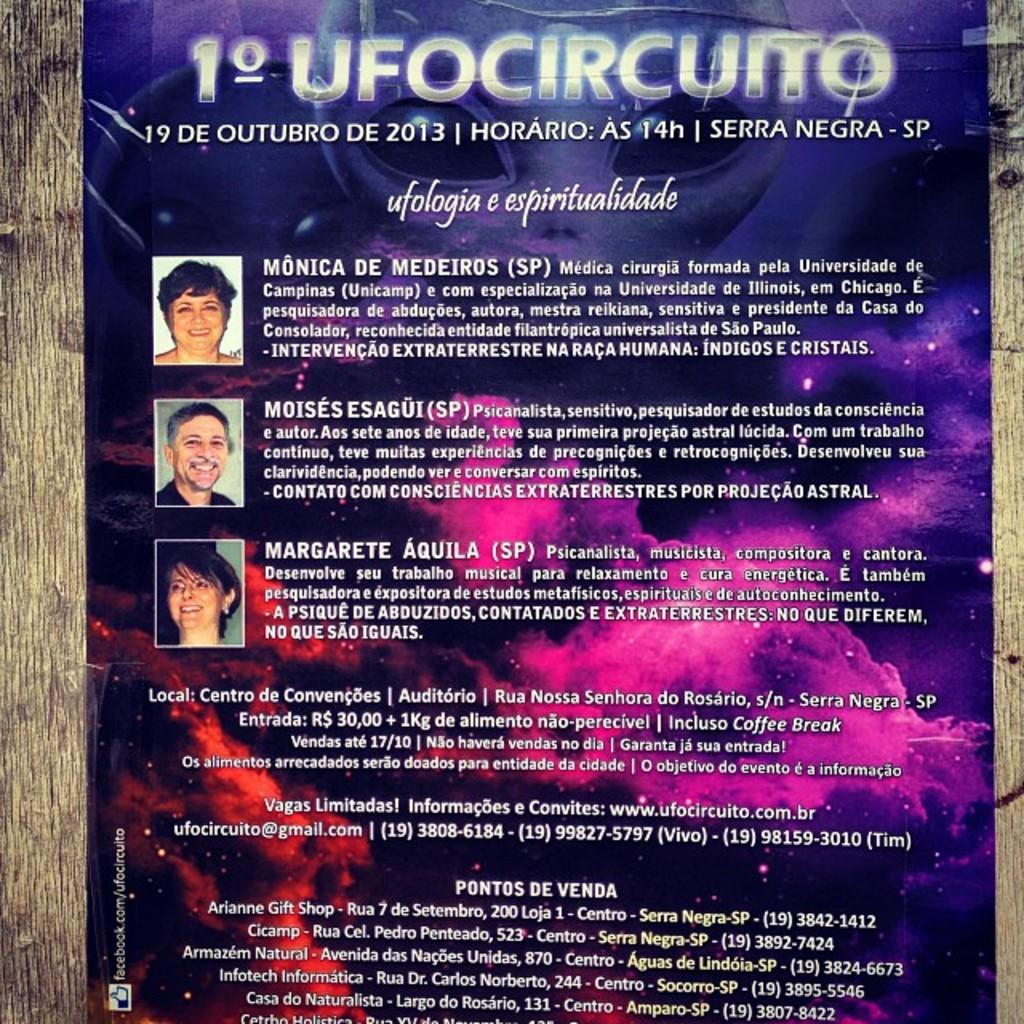What is featured on the poster in the image? The poster contains three pictures of persons. Is there any text on the poster? Yes, there is text on the poster. What material can be seen on the left side of the image? There is wood on the left side of the image. What material can be seen on the right side of the image? There is wood on the right side of the image. What type of wool is being used to balance the powder in the image? There is no wool, balance, or powder present in the image. 